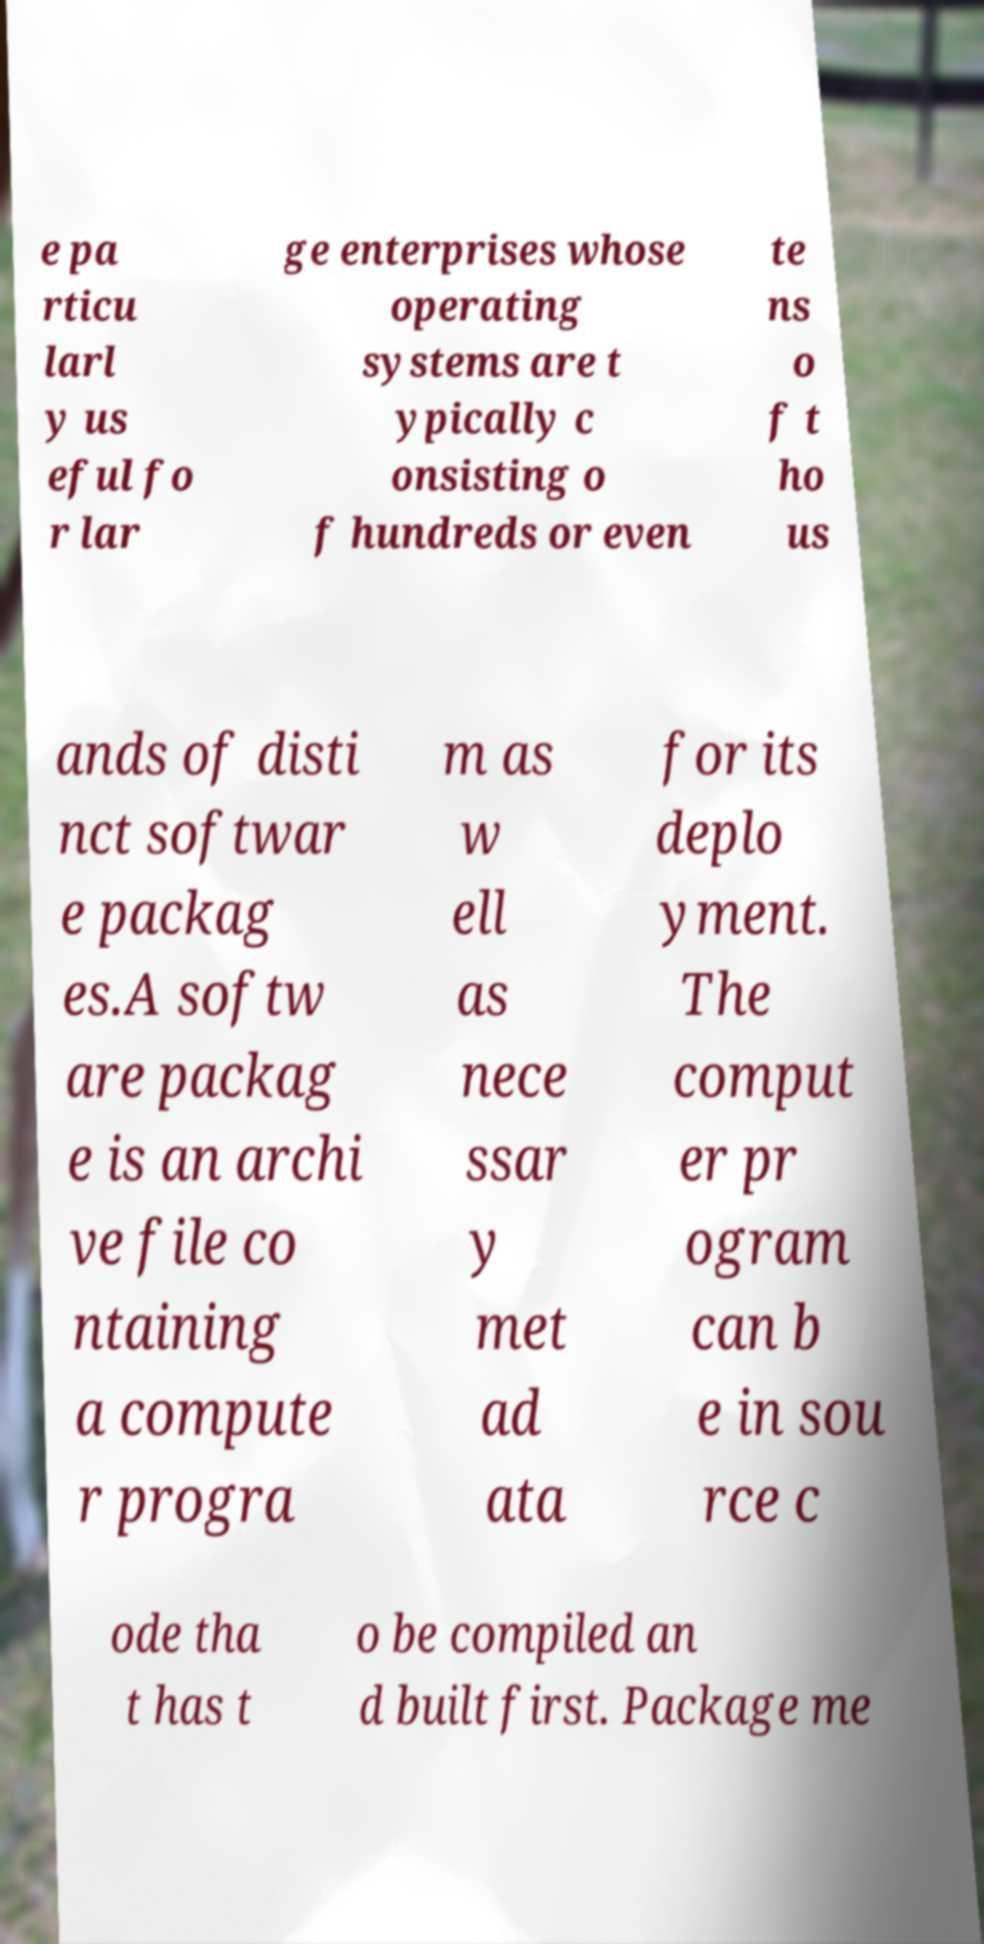Please identify and transcribe the text found in this image. e pa rticu larl y us eful fo r lar ge enterprises whose operating systems are t ypically c onsisting o f hundreds or even te ns o f t ho us ands of disti nct softwar e packag es.A softw are packag e is an archi ve file co ntaining a compute r progra m as w ell as nece ssar y met ad ata for its deplo yment. The comput er pr ogram can b e in sou rce c ode tha t has t o be compiled an d built first. Package me 